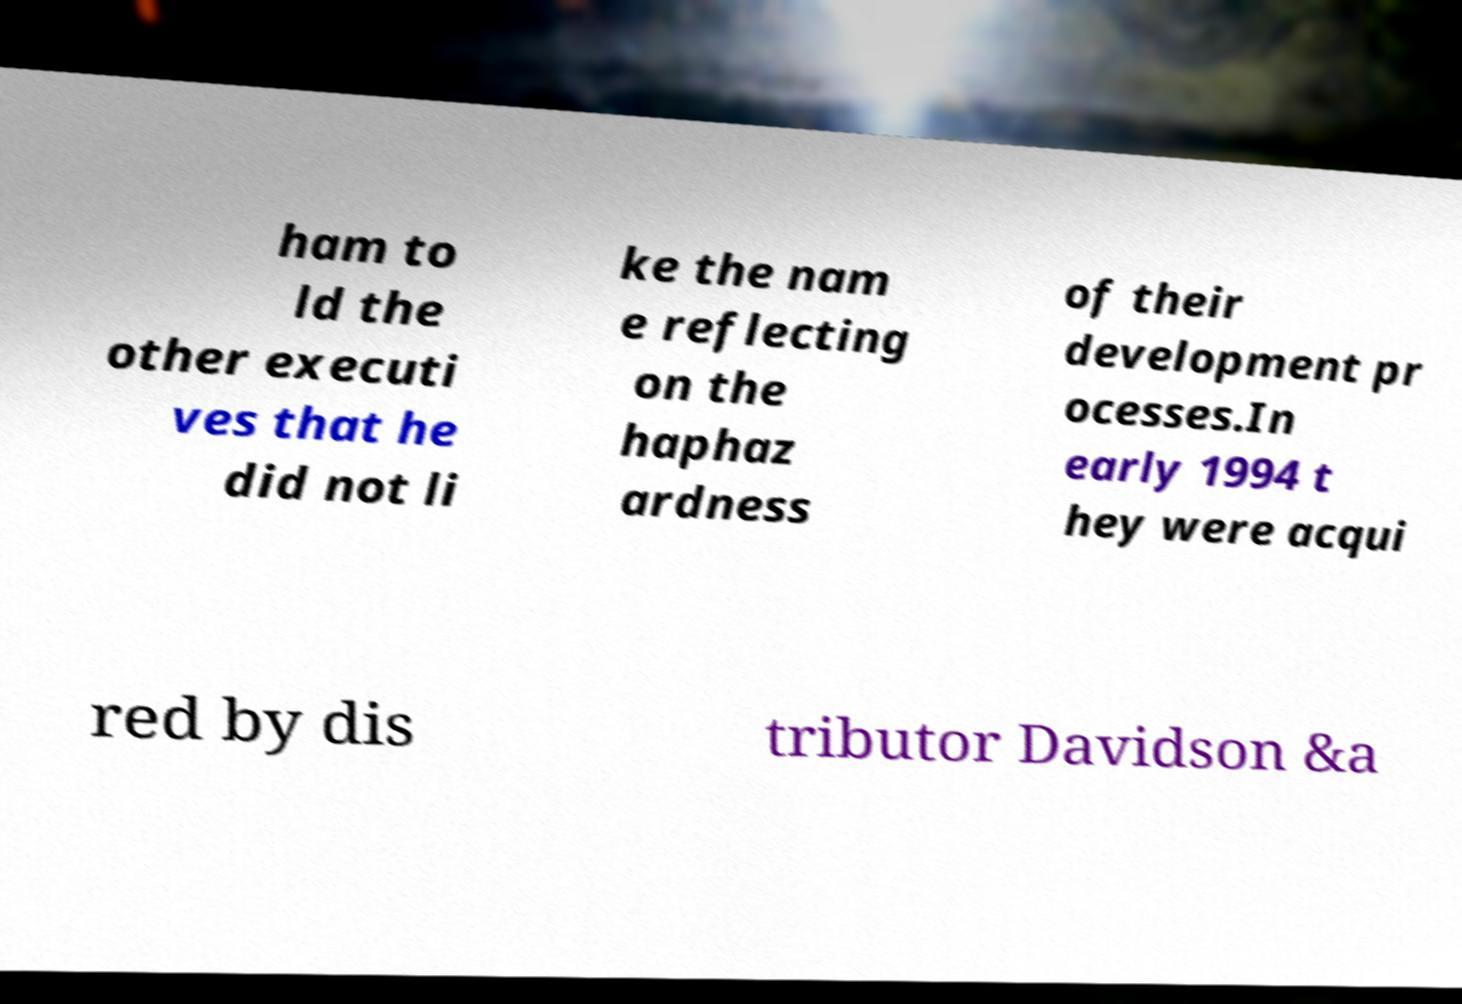Please read and relay the text visible in this image. What does it say? ham to ld the other executi ves that he did not li ke the nam e reflecting on the haphaz ardness of their development pr ocesses.In early 1994 t hey were acqui red by dis tributor Davidson &a 